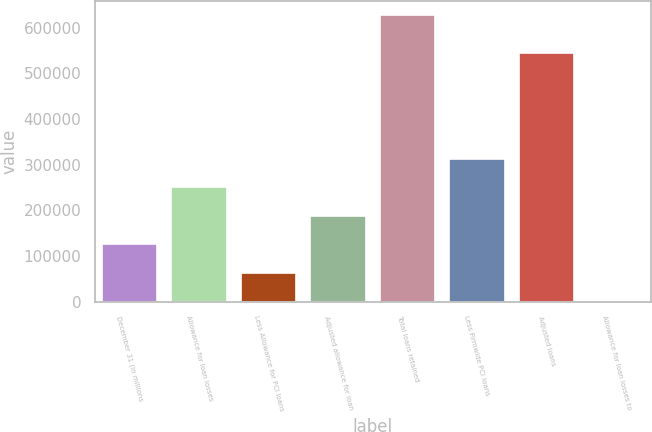Convert chart. <chart><loc_0><loc_0><loc_500><loc_500><bar_chart><fcel>December 31 (in millions<fcel>Allowance for loan losses<fcel>Less Allowance for PCI loans<fcel>Adjusted allowance for loan<fcel>Total loans retained<fcel>Less Firmwide PCI loans<fcel>Adjusted loans<fcel>Allowance for loan losses to<nl><fcel>125448<fcel>250891<fcel>62726.8<fcel>188169<fcel>627218<fcel>313612<fcel>544836<fcel>5.51<nl></chart> 